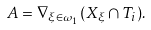Convert formula to latex. <formula><loc_0><loc_0><loc_500><loc_500>A = \nabla _ { \xi \in \omega _ { 1 } } ( X _ { \xi } \cap T _ { i } ) .</formula> 